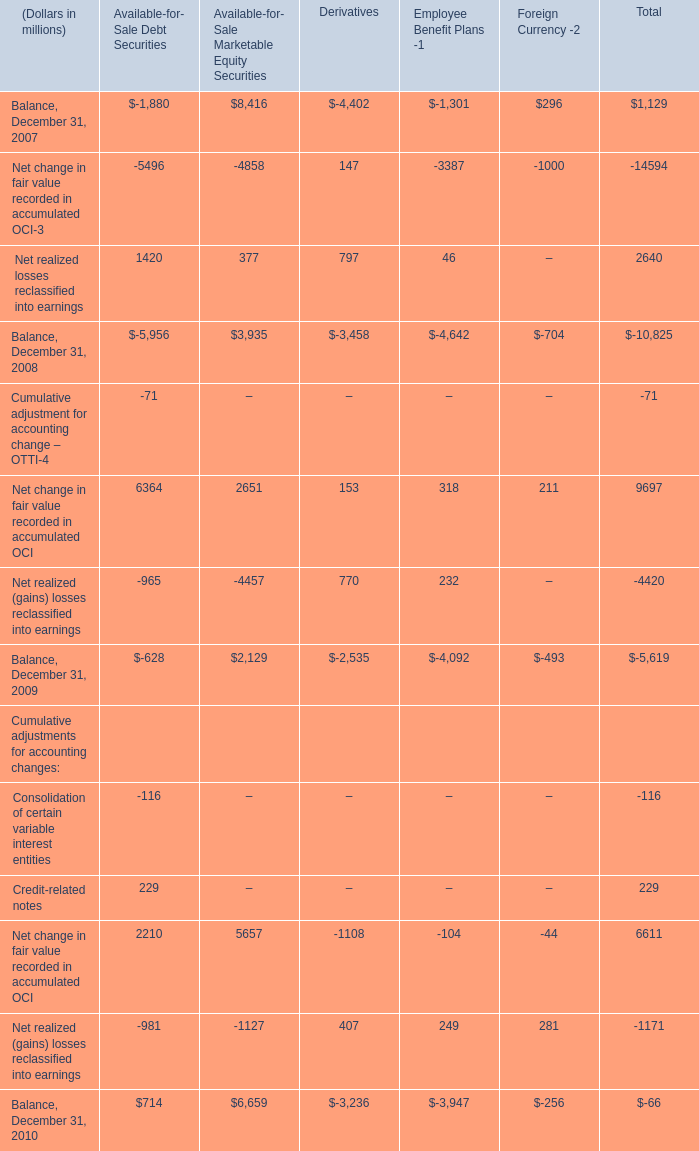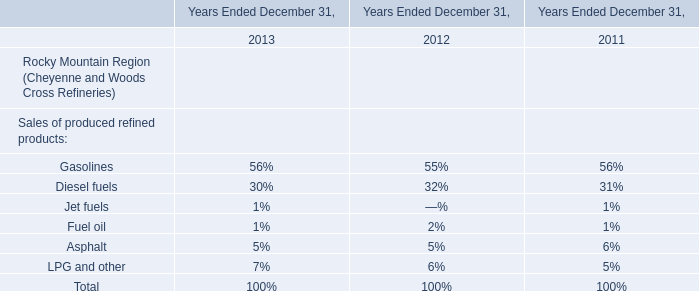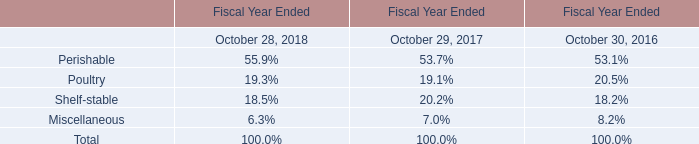In which year is Available-for- Sale Marketable Equity Securities greater than 8000? 
Answer: Balance, December 31, 2007. 